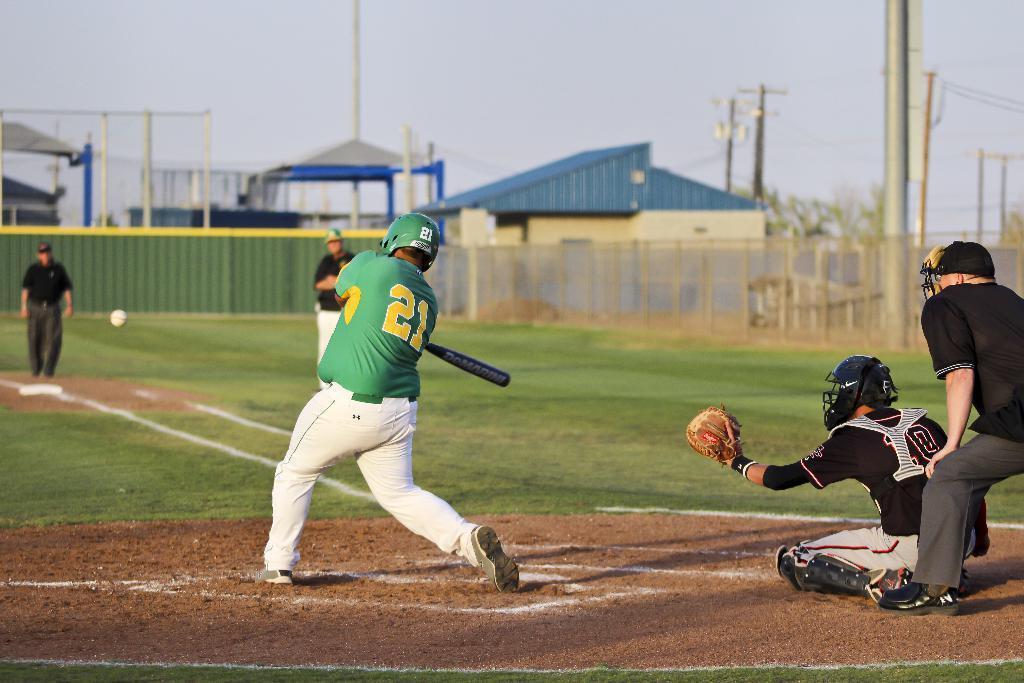Please provide a concise description of this image. In this picture we can see five people on the ground, ball is in the air, grass, bat, helmets, wall, fence, trees, sheds, some objects and in the background we can see the sky. 